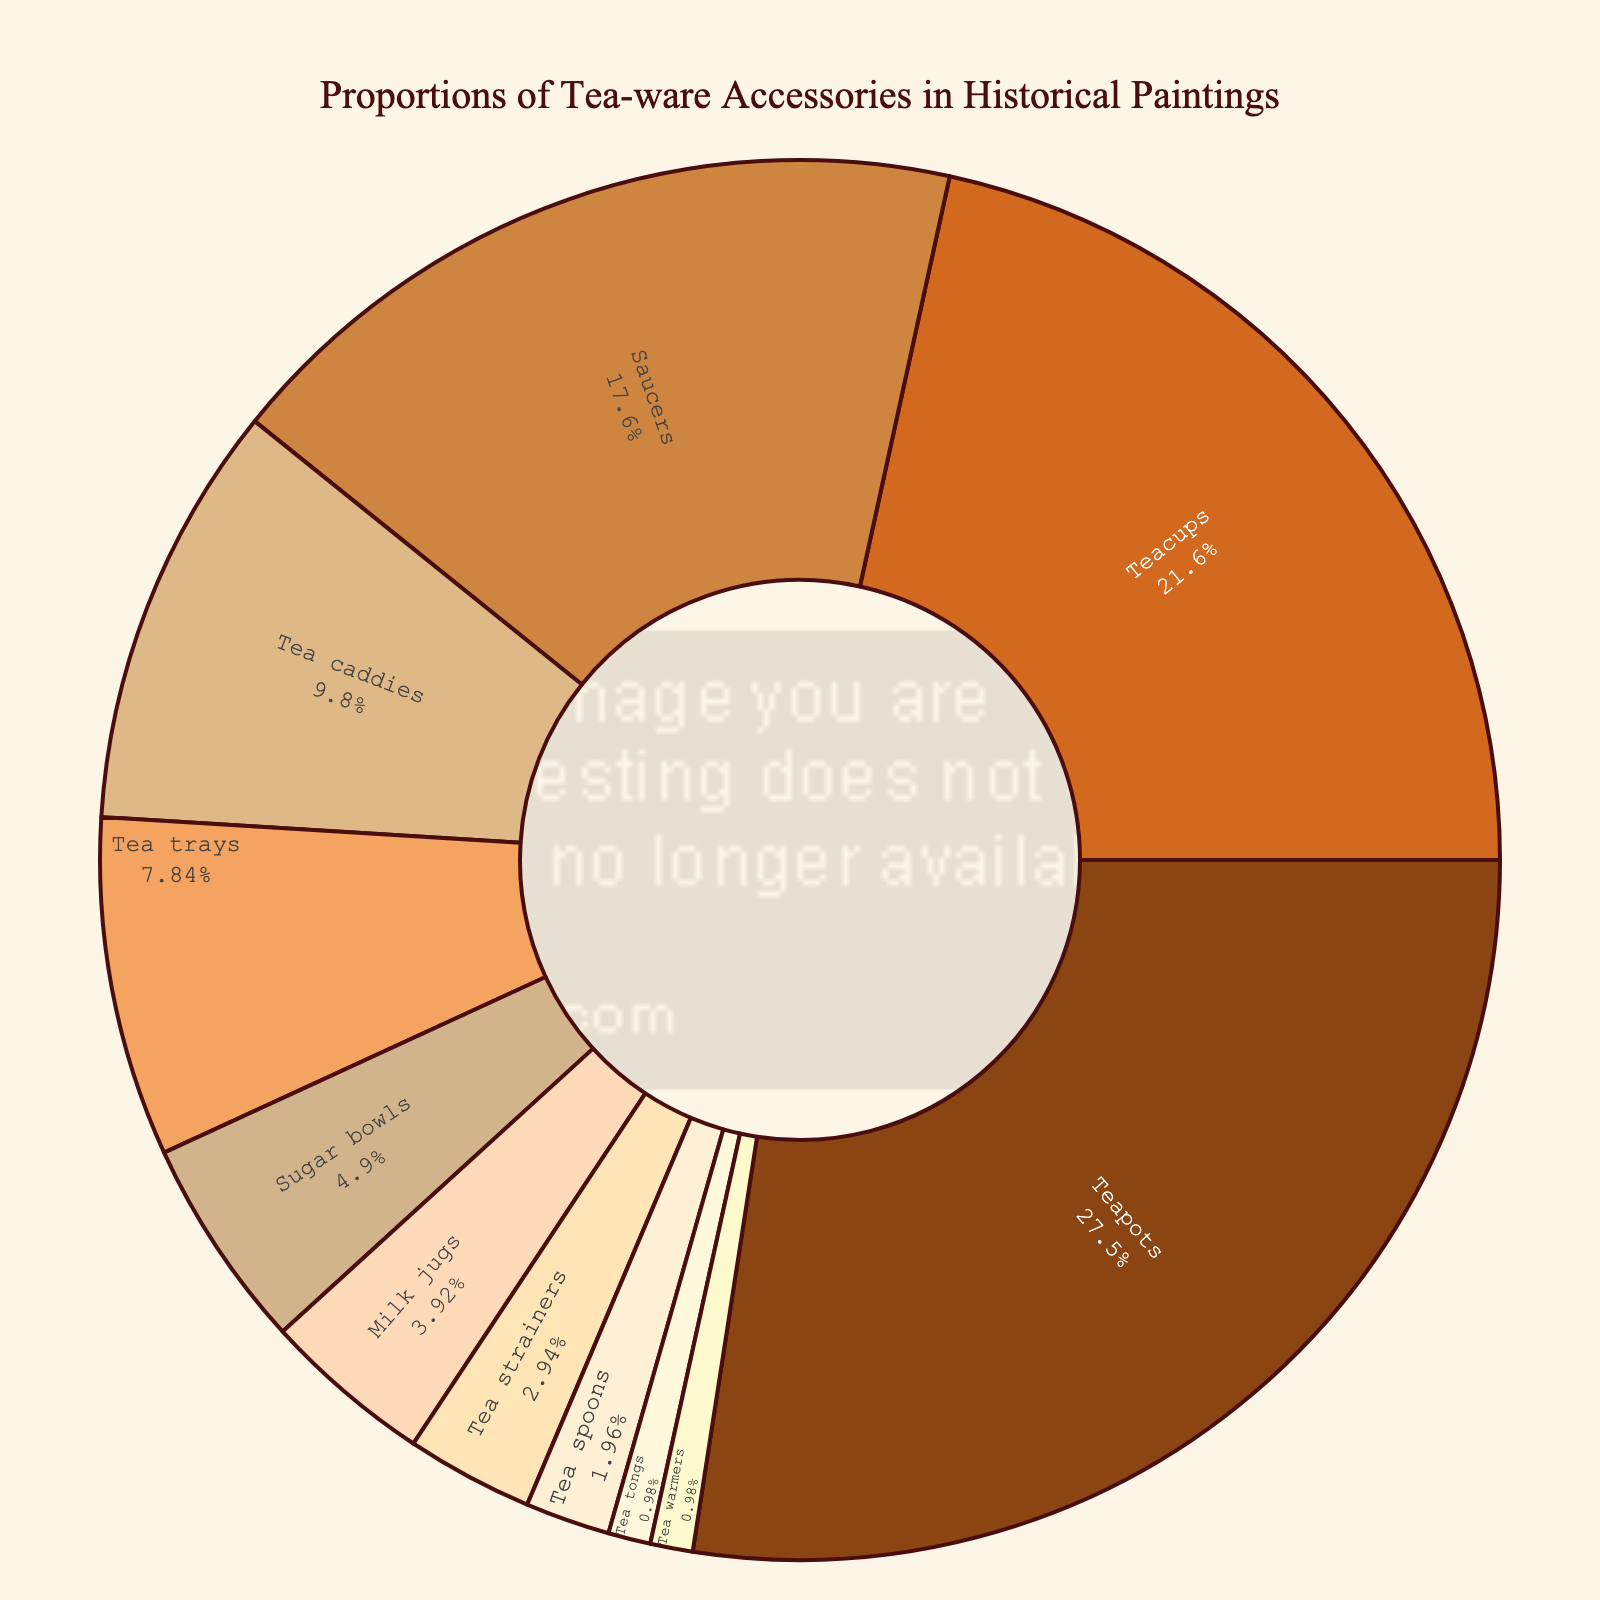Which tea-ware accessory has the highest proportion depicted in historical paintings? The pie chart shows that teapots have the largest segment with the label indicating 28%. Therefore, teapots have the highest proportion.
Answer: Teapots Which two categories have the closest proportion percentages? By looking at the pie chart, tea warmers and tea tongs each have 1%, making them the two categories with the closest proportions.
Answer: Tea warmers and tea tongs How many categories have a proportion of 10% or more? From the pie chart: teapots (28%), teacups (22%), saucers (18%), and tea caddies (10%) are all categories with 10% or more.
Answer: Four categories What is the difference in percentage between teacups and saucers? The pie chart shows that teacups are 22% and saucers are 18%. The percentage difference is 22% - 18% = 4%.
Answer: 4% Which category represents the exact middle value when sorted by percentage? Sorting the categories by percentage, the middle value is tea trays at 8%, as it sits in the 6th position out of 11 categories.
Answer: Tea trays What is the combined percentage of accessories related to sugar and milk? The combined percentage for sugar bowls (5%) and milk jugs (4%) is 5% + 4% = 9%.
Answer: 9% Are there more categories above or below the 5% threshold? There are five categories above 5% (teapots, teacups, saucers, tea caddies, and tea trays) and six categories below or equal to 5% (sugar bowls, milk jugs, tea strainers, tea spoons, tea tongs, and tea warmers). Therefore, more categories are below the threshold.
Answer: Below What is the average percentage of the three smallest categories? The smallest three categories are tea spoons (2%), tea tongs (1%), and tea warmers (1%). The average is (2% + 1% + 1%) / 3 = 1.33%.
Answer: 1.33% How much larger is the proportion of teapots compared to the total proportion of teapots, tea caddies, and tea trays combined? Teapots are 28%. The combined proportion of teapots (28%), tea caddies (10%), and tea trays (8%) is 46%. The difference is 46% - 28% = 18%.
Answer: 18% Which category depicted in the pie chart has the least representation in historical paintings? The pie chart shows that both tea warmers and tea tongs have the smallest segment, each with 1%.
Answer: Tea warmers and tea tongs 